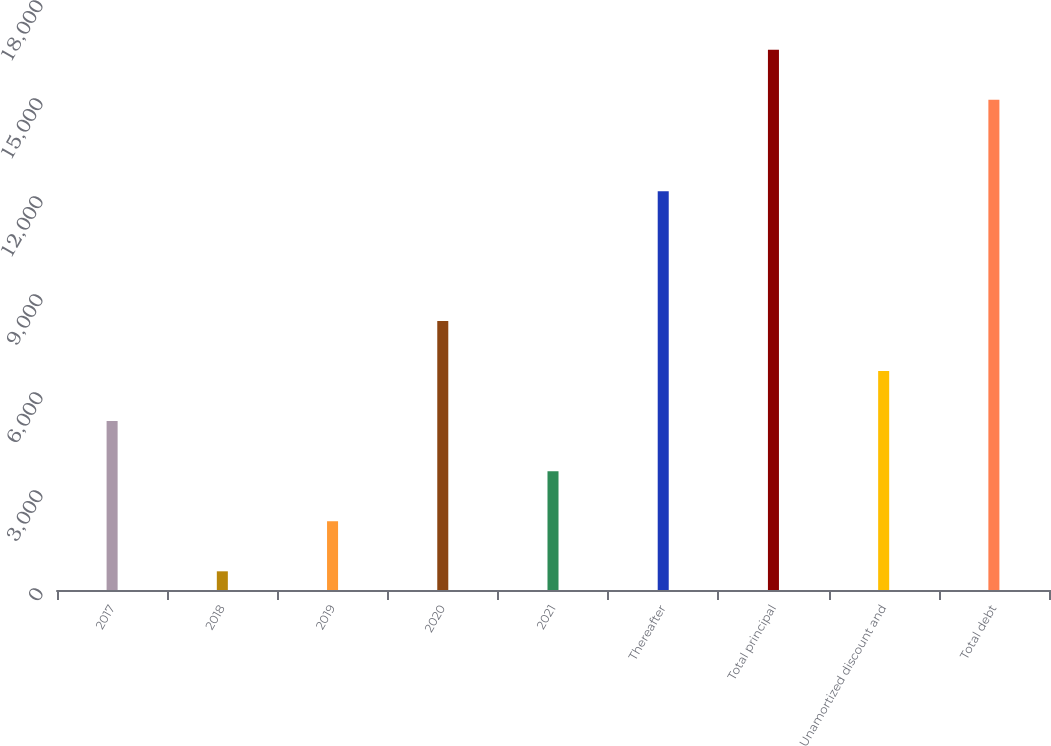<chart> <loc_0><loc_0><loc_500><loc_500><bar_chart><fcel>2017<fcel>2018<fcel>2019<fcel>2020<fcel>2021<fcel>Thereafter<fcel>Total principal<fcel>Unamortized discount and<fcel>Total debt<nl><fcel>5170.7<fcel>572<fcel>2104.9<fcel>8236.5<fcel>3637.8<fcel>12206<fcel>16539.9<fcel>6703.6<fcel>15007<nl></chart> 